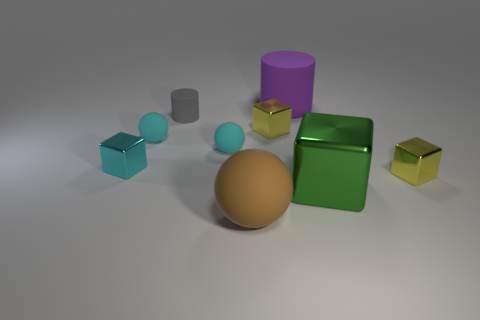Subtract all big balls. How many balls are left? 2 Subtract all cyan balls. How many balls are left? 1 Add 1 small gray rubber objects. How many objects exist? 10 Subtract all balls. How many objects are left? 6 Subtract 1 balls. How many balls are left? 2 Subtract all cyan objects. Subtract all large brown spheres. How many objects are left? 5 Add 1 tiny things. How many tiny things are left? 7 Add 5 tiny gray things. How many tiny gray things exist? 6 Subtract 1 gray cylinders. How many objects are left? 8 Subtract all yellow balls. Subtract all blue cylinders. How many balls are left? 3 